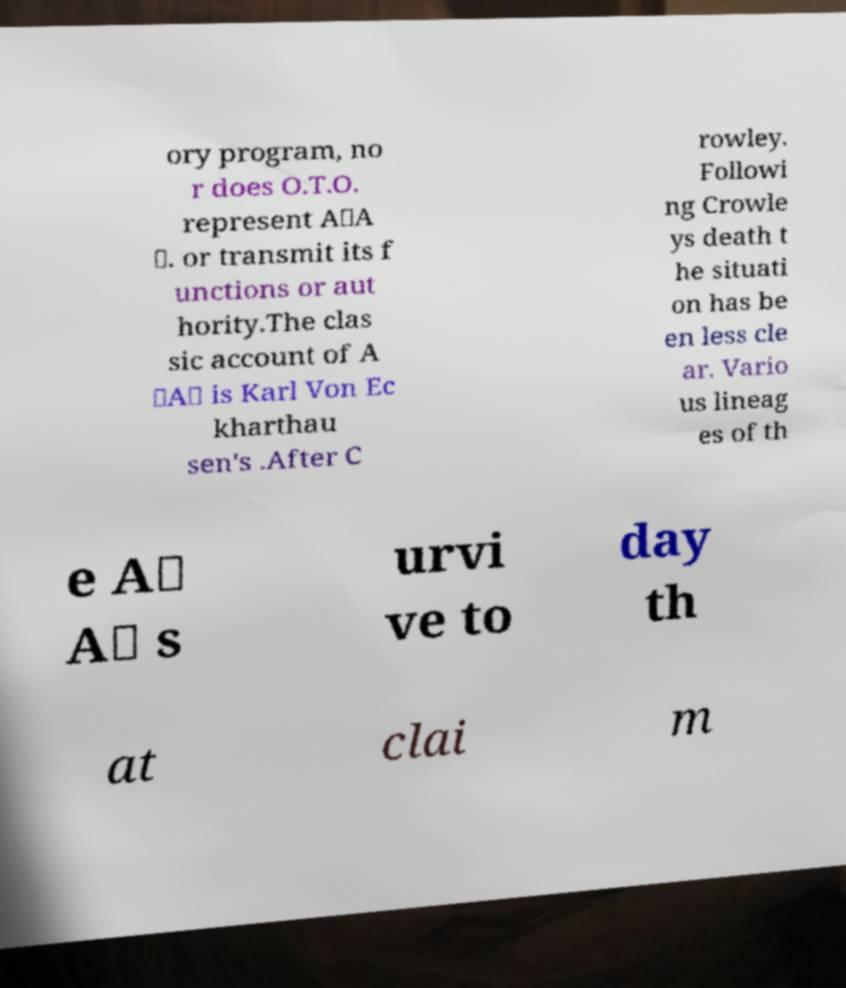For documentation purposes, I need the text within this image transcribed. Could you provide that? ory program, no r does O.T.O. represent A∴A ∴. or transmit its f unctions or aut hority.The clas sic account of A ∴A∴ is Karl Von Ec kharthau sen's .After C rowley. Followi ng Crowle ys death t he situati on has be en less cle ar. Vario us lineag es of th e A∴ A∴ s urvi ve to day th at clai m 